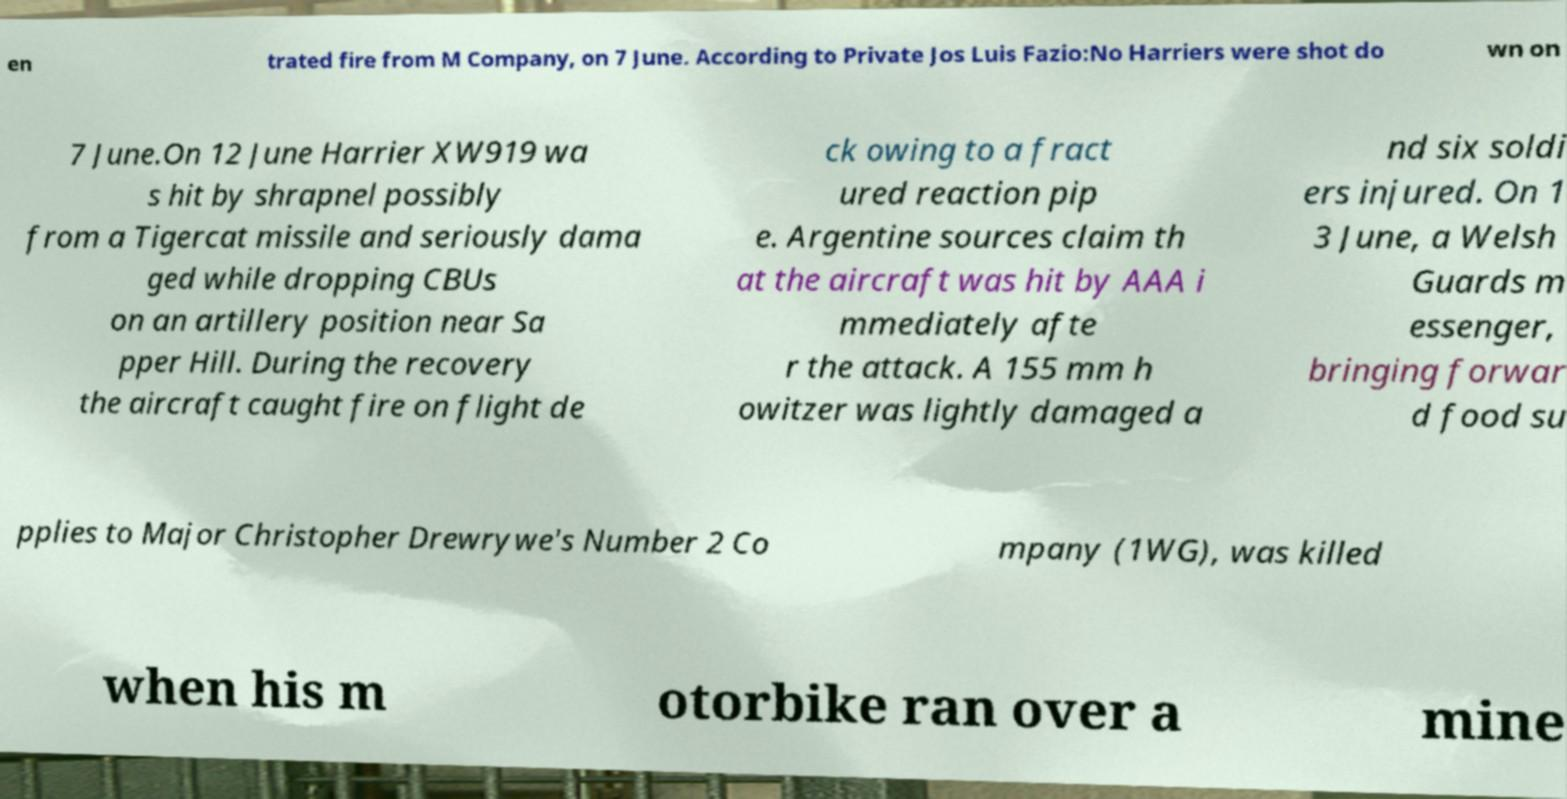Please identify and transcribe the text found in this image. en trated fire from M Company, on 7 June. According to Private Jos Luis Fazio:No Harriers were shot do wn on 7 June.On 12 June Harrier XW919 wa s hit by shrapnel possibly from a Tigercat missile and seriously dama ged while dropping CBUs on an artillery position near Sa pper Hill. During the recovery the aircraft caught fire on flight de ck owing to a fract ured reaction pip e. Argentine sources claim th at the aircraft was hit by AAA i mmediately afte r the attack. A 155 mm h owitzer was lightly damaged a nd six soldi ers injured. On 1 3 June, a Welsh Guards m essenger, bringing forwar d food su pplies to Major Christopher Drewrywe's Number 2 Co mpany (1WG), was killed when his m otorbike ran over a mine 